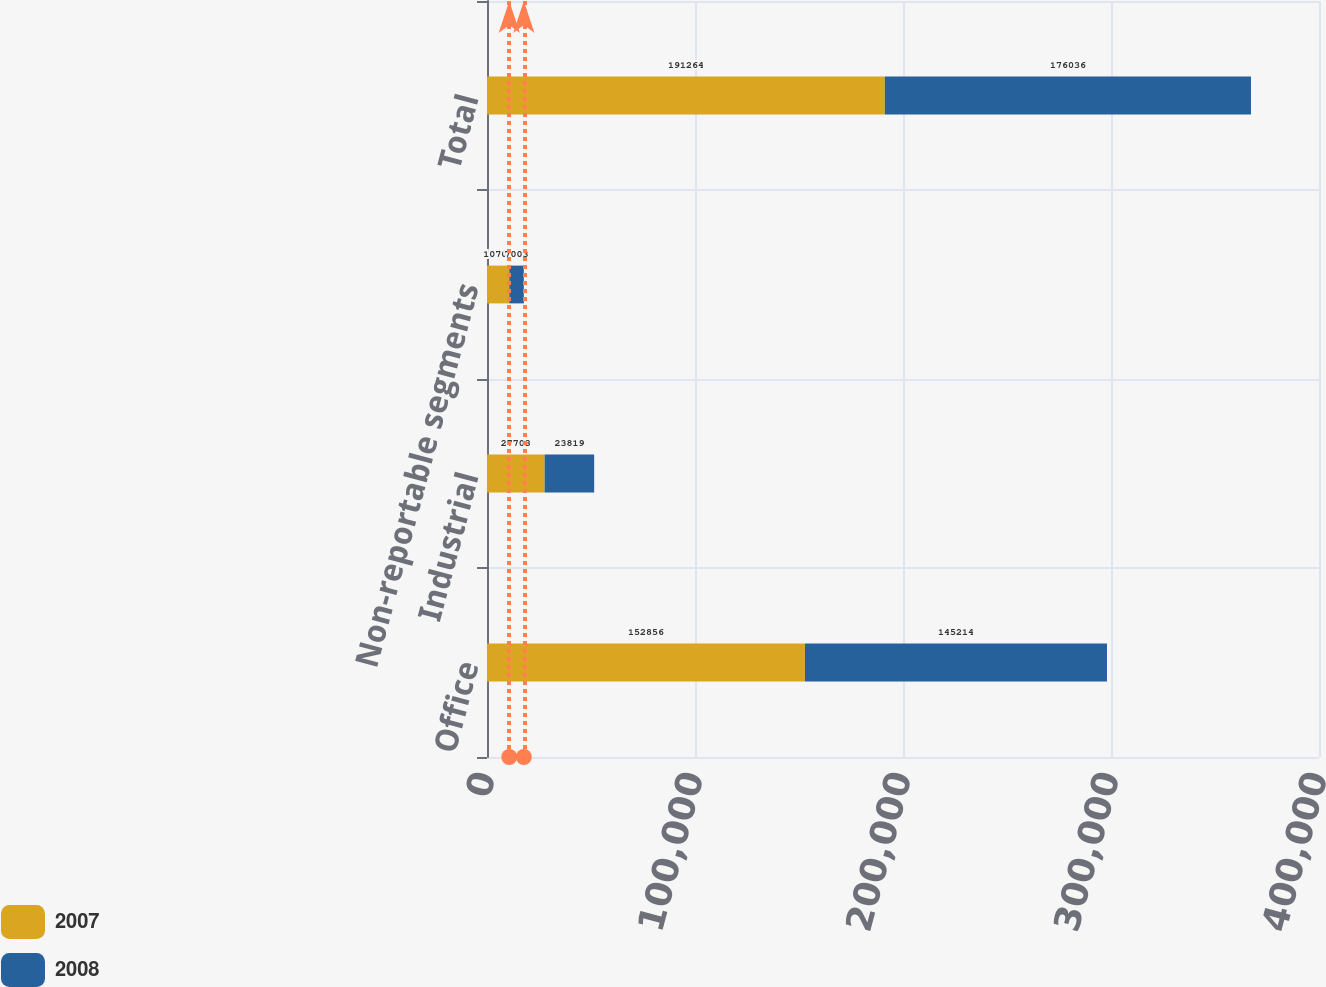<chart> <loc_0><loc_0><loc_500><loc_500><stacked_bar_chart><ecel><fcel>Office<fcel>Industrial<fcel>Non-reportable segments<fcel>Total<nl><fcel>2007<fcel>152856<fcel>27703<fcel>10705<fcel>191264<nl><fcel>2008<fcel>145214<fcel>23819<fcel>7003<fcel>176036<nl></chart> 